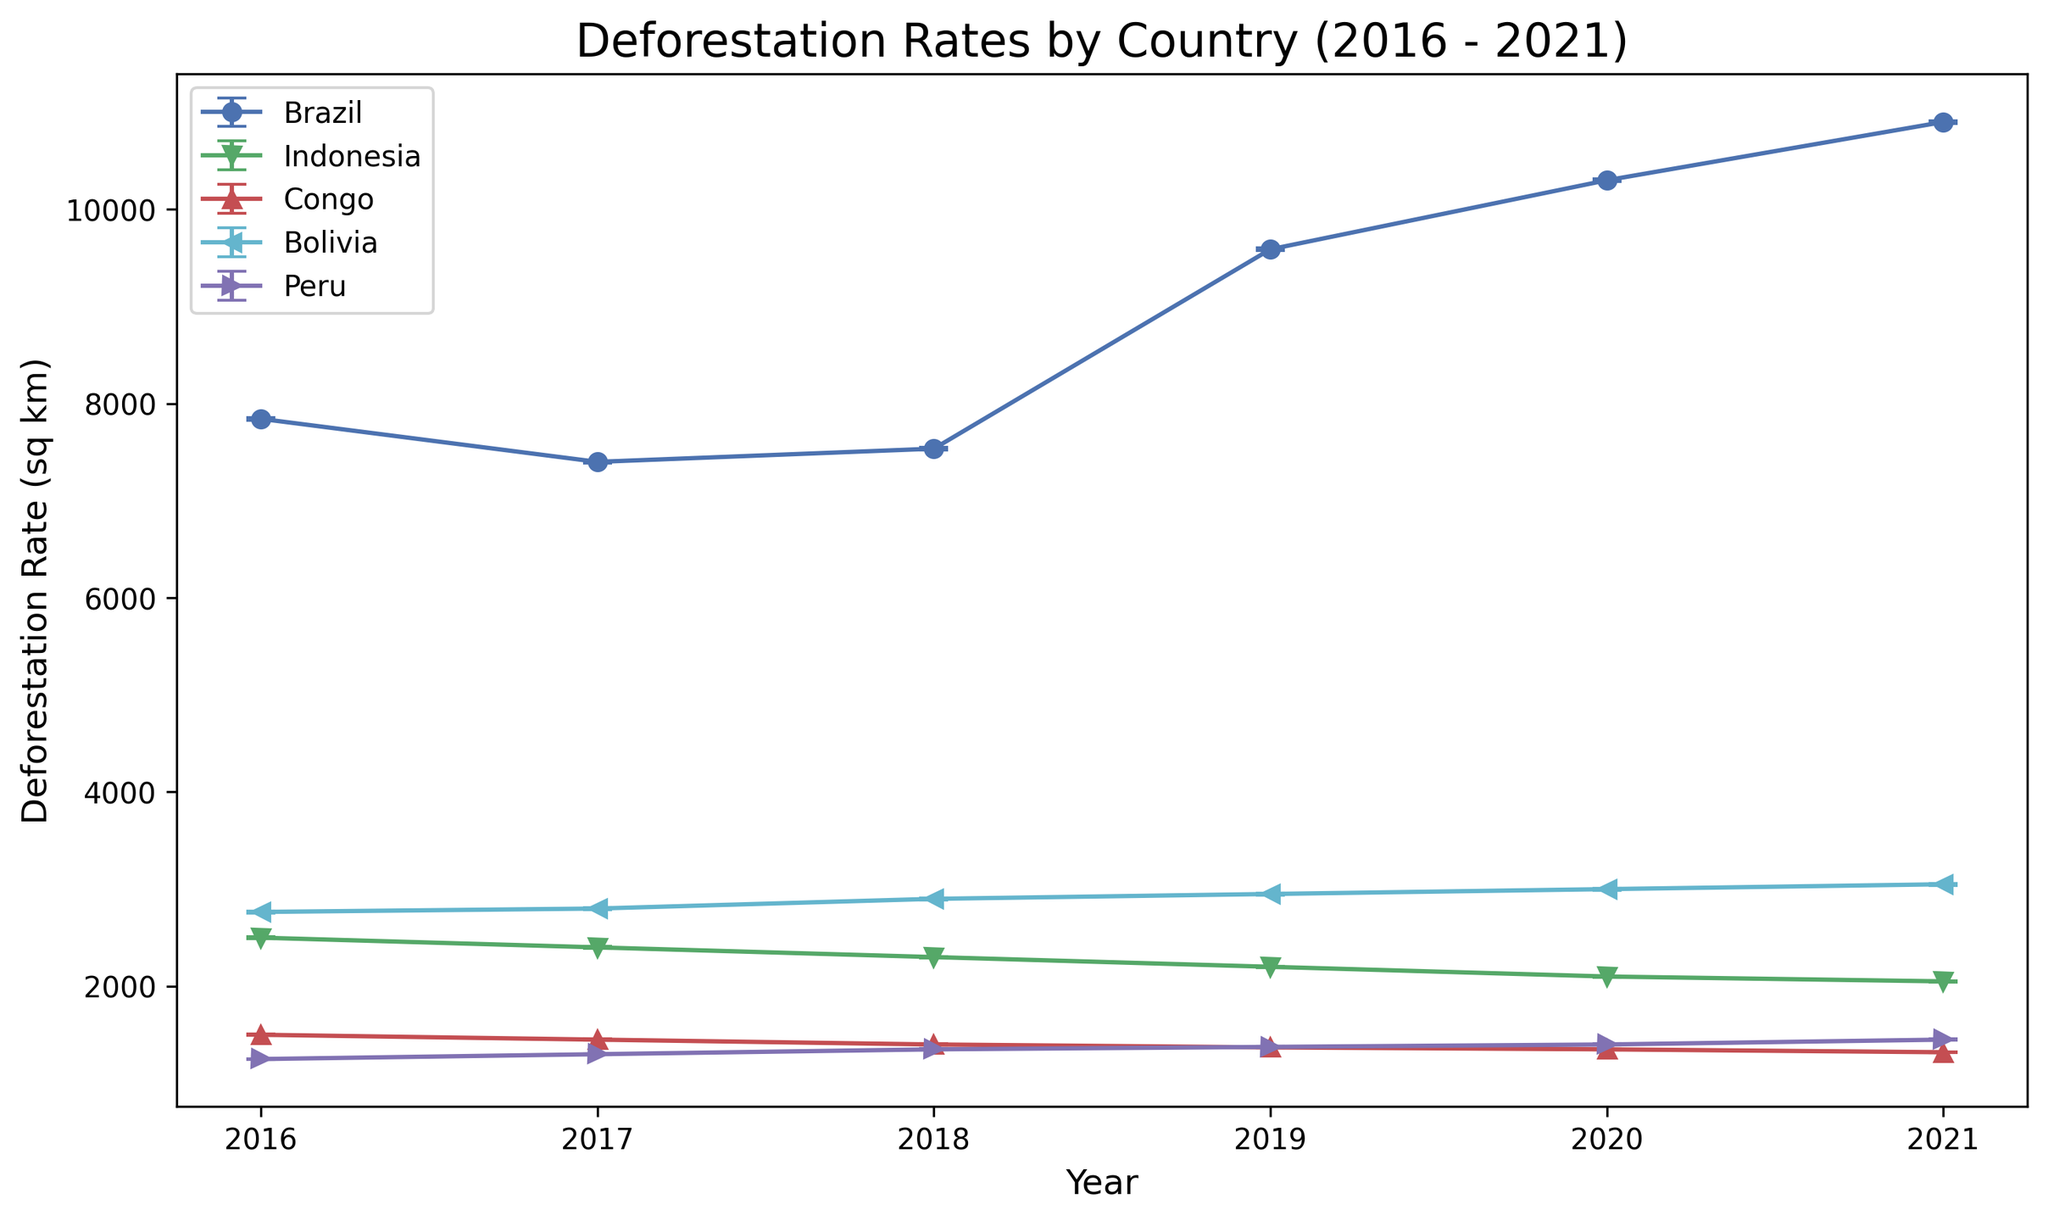Which country had the highest deforestation rate in 2021? To determine the country with the highest deforestation rate in 2021, examine the data points for all countries in 2021. Brazil had a deforestation rate of 10900 sq km, which is the highest in that year.
Answer: Brazil Which country showed a consistent decline in deforestation rates from 2016 to 2021? Reviewing the lines and trends on the plot, Indonesia and Congo both show consistent declines in deforestation rates from 2016 to 2021. While Peru's trend is also downward, it is not as consistent as Indonesia and Congo.
Answer: Indonesia and Congo What is the difference in the deforestation rate between Brazil and Indonesia in 2020? Find the deforestation rates for Brazil and Indonesia in 2020, which are 10300 sq km and 2100 sq km, respectively. The difference between the two is 10300 - 2100 = 8200 sq km.
Answer: 8200 sq km Which country had the smallest error range in its deforestation rate in 2016? Examine the error bars for each country in 2016. Congo has an error of 6.3, which is the smallest among all the countries listed.
Answer: Congo What was the average deforestation rate for Peru from 2016 to 2021? Calculate the average by summing Peru's deforestation rates for each year and dividing by the number of years: (1250 + 1300 + 1350 + 1375 + 1400 + 1450) / 6 = 1370.8 sq km.
Answer: 1370.8 sq km By how much did Bolivia's deforestation rate increase from 2016 to 2021? Subtract Bolivia's deforestation rate in 2016 from that in 2021: 3050 sq km (2021) - 2765 sq km (2016) = 285 sq km.
Answer: 285 sq km Which country had a deforestation rate closest to 1500 sq km in any year? Compare the deforestation rates across all countries and years. Congo had a deforestation rate of 1500 sq km in 2016, which is the closest to this value.
Answer: Congo What is the overall trend in deforestation rates for Brazil from 2016 to 2021, and how does it compare to that of Peru? Brazil's deforestation rates increase from 7843 sq km in 2016 to 10900 sq km in 2021, showing an upward trend. In contrast, Peru's deforestation increases slightly from 1250 sq km in 2016 to 1450 sq km in 2021 but at a much slower rate.
Answer: Brazil's rate is increasing rapidly, while Peru's rate is increasing slowly 